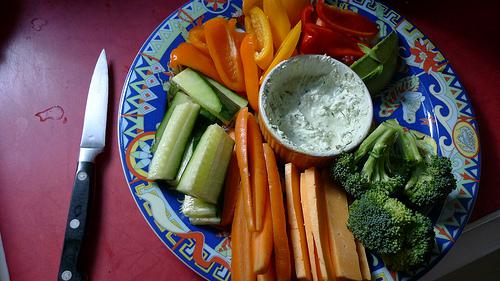Question: where is plate of food on?
Choices:
A. On a table.
B. On a counter.
C. On a couch.
D. On a sink.
Answer with the letter. Answer: A Question: what is this a photo of?
Choices:
A. Fruits.
B. Meats.
C. Cheese.
D. Vegetables.
Answer with the letter. Answer: D 